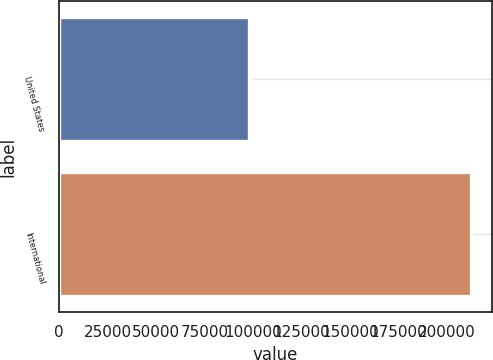Convert chart. <chart><loc_0><loc_0><loc_500><loc_500><bar_chart><fcel>United States<fcel>International<nl><fcel>98180<fcel>212733<nl></chart> 